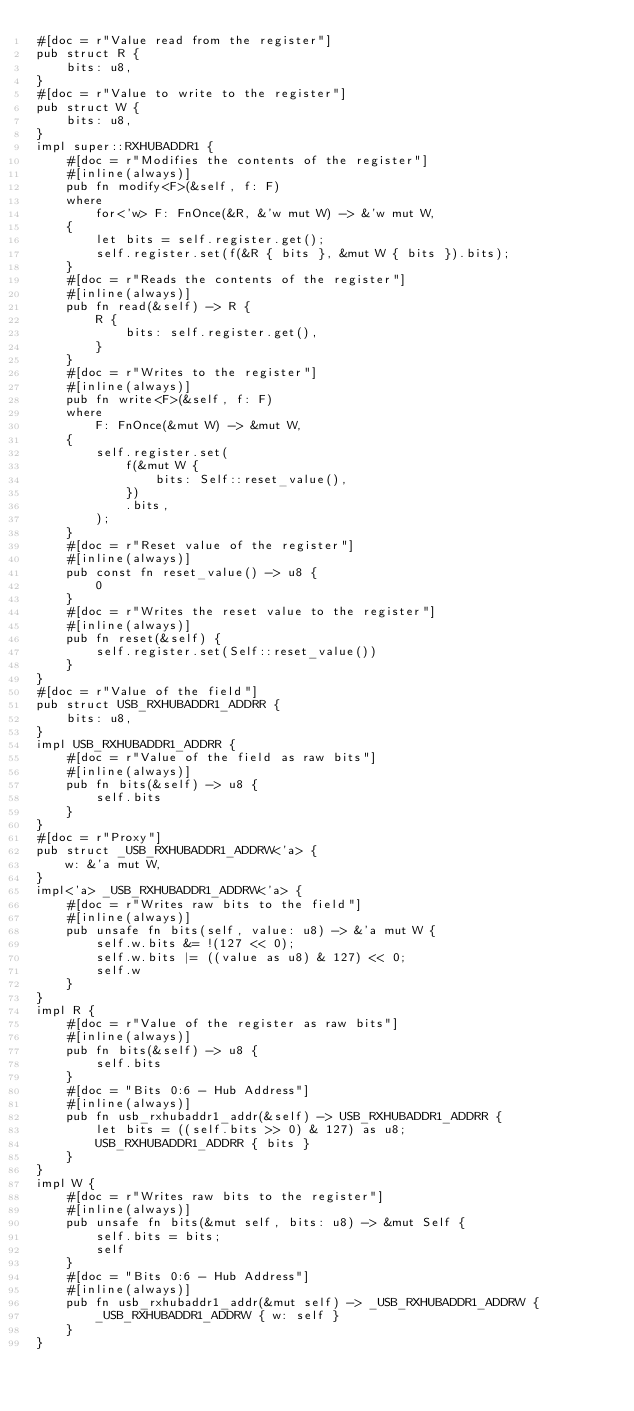Convert code to text. <code><loc_0><loc_0><loc_500><loc_500><_Rust_>#[doc = r"Value read from the register"]
pub struct R {
    bits: u8,
}
#[doc = r"Value to write to the register"]
pub struct W {
    bits: u8,
}
impl super::RXHUBADDR1 {
    #[doc = r"Modifies the contents of the register"]
    #[inline(always)]
    pub fn modify<F>(&self, f: F)
    where
        for<'w> F: FnOnce(&R, &'w mut W) -> &'w mut W,
    {
        let bits = self.register.get();
        self.register.set(f(&R { bits }, &mut W { bits }).bits);
    }
    #[doc = r"Reads the contents of the register"]
    #[inline(always)]
    pub fn read(&self) -> R {
        R {
            bits: self.register.get(),
        }
    }
    #[doc = r"Writes to the register"]
    #[inline(always)]
    pub fn write<F>(&self, f: F)
    where
        F: FnOnce(&mut W) -> &mut W,
    {
        self.register.set(
            f(&mut W {
                bits: Self::reset_value(),
            })
            .bits,
        );
    }
    #[doc = r"Reset value of the register"]
    #[inline(always)]
    pub const fn reset_value() -> u8 {
        0
    }
    #[doc = r"Writes the reset value to the register"]
    #[inline(always)]
    pub fn reset(&self) {
        self.register.set(Self::reset_value())
    }
}
#[doc = r"Value of the field"]
pub struct USB_RXHUBADDR1_ADDRR {
    bits: u8,
}
impl USB_RXHUBADDR1_ADDRR {
    #[doc = r"Value of the field as raw bits"]
    #[inline(always)]
    pub fn bits(&self) -> u8 {
        self.bits
    }
}
#[doc = r"Proxy"]
pub struct _USB_RXHUBADDR1_ADDRW<'a> {
    w: &'a mut W,
}
impl<'a> _USB_RXHUBADDR1_ADDRW<'a> {
    #[doc = r"Writes raw bits to the field"]
    #[inline(always)]
    pub unsafe fn bits(self, value: u8) -> &'a mut W {
        self.w.bits &= !(127 << 0);
        self.w.bits |= ((value as u8) & 127) << 0;
        self.w
    }
}
impl R {
    #[doc = r"Value of the register as raw bits"]
    #[inline(always)]
    pub fn bits(&self) -> u8 {
        self.bits
    }
    #[doc = "Bits 0:6 - Hub Address"]
    #[inline(always)]
    pub fn usb_rxhubaddr1_addr(&self) -> USB_RXHUBADDR1_ADDRR {
        let bits = ((self.bits >> 0) & 127) as u8;
        USB_RXHUBADDR1_ADDRR { bits }
    }
}
impl W {
    #[doc = r"Writes raw bits to the register"]
    #[inline(always)]
    pub unsafe fn bits(&mut self, bits: u8) -> &mut Self {
        self.bits = bits;
        self
    }
    #[doc = "Bits 0:6 - Hub Address"]
    #[inline(always)]
    pub fn usb_rxhubaddr1_addr(&mut self) -> _USB_RXHUBADDR1_ADDRW {
        _USB_RXHUBADDR1_ADDRW { w: self }
    }
}
</code> 